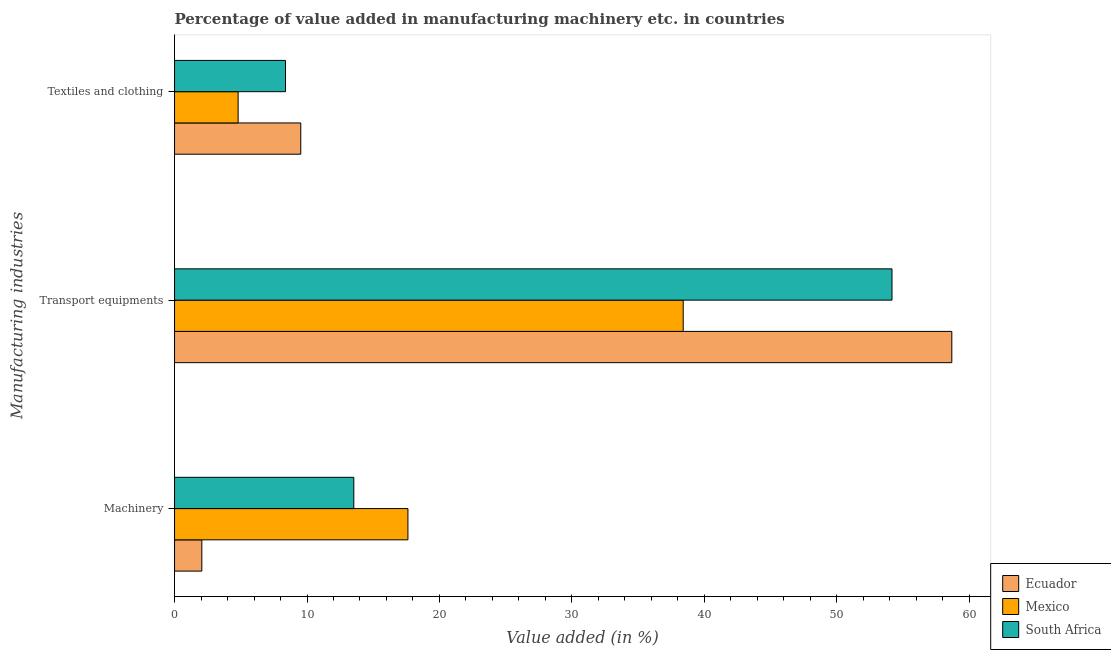How many groups of bars are there?
Keep it short and to the point. 3. Are the number of bars per tick equal to the number of legend labels?
Give a very brief answer. Yes. Are the number of bars on each tick of the Y-axis equal?
Offer a terse response. Yes. How many bars are there on the 2nd tick from the top?
Offer a very short reply. 3. How many bars are there on the 1st tick from the bottom?
Provide a short and direct response. 3. What is the label of the 3rd group of bars from the top?
Your answer should be very brief. Machinery. What is the value added in manufacturing textile and clothing in Ecuador?
Give a very brief answer. 9.53. Across all countries, what is the maximum value added in manufacturing machinery?
Your answer should be very brief. 17.62. Across all countries, what is the minimum value added in manufacturing machinery?
Ensure brevity in your answer.  2.06. In which country was the value added in manufacturing transport equipments maximum?
Provide a short and direct response. Ecuador. In which country was the value added in manufacturing machinery minimum?
Offer a very short reply. Ecuador. What is the total value added in manufacturing textile and clothing in the graph?
Offer a terse response. 22.71. What is the difference between the value added in manufacturing textile and clothing in Ecuador and that in South Africa?
Ensure brevity in your answer.  1.15. What is the difference between the value added in manufacturing machinery in South Africa and the value added in manufacturing transport equipments in Ecuador?
Offer a very short reply. -45.15. What is the average value added in manufacturing machinery per country?
Provide a short and direct response. 11.07. What is the difference between the value added in manufacturing textile and clothing and value added in manufacturing transport equipments in Ecuador?
Make the answer very short. -49.16. In how many countries, is the value added in manufacturing transport equipments greater than 52 %?
Provide a succinct answer. 2. What is the ratio of the value added in manufacturing machinery in South Africa to that in Ecuador?
Ensure brevity in your answer.  6.57. Is the value added in manufacturing transport equipments in Ecuador less than that in South Africa?
Offer a terse response. No. What is the difference between the highest and the second highest value added in manufacturing textile and clothing?
Give a very brief answer. 1.15. What is the difference between the highest and the lowest value added in manufacturing transport equipments?
Provide a short and direct response. 20.28. What does the 2nd bar from the top in Transport equipments represents?
Your response must be concise. Mexico. How many bars are there?
Offer a terse response. 9. Does the graph contain grids?
Your answer should be compact. No. Where does the legend appear in the graph?
Offer a terse response. Bottom right. How many legend labels are there?
Make the answer very short. 3. How are the legend labels stacked?
Ensure brevity in your answer.  Vertical. What is the title of the graph?
Make the answer very short. Percentage of value added in manufacturing machinery etc. in countries. Does "Angola" appear as one of the legend labels in the graph?
Give a very brief answer. No. What is the label or title of the X-axis?
Provide a succinct answer. Value added (in %). What is the label or title of the Y-axis?
Make the answer very short. Manufacturing industries. What is the Value added (in %) in Ecuador in Machinery?
Keep it short and to the point. 2.06. What is the Value added (in %) of Mexico in Machinery?
Keep it short and to the point. 17.62. What is the Value added (in %) of South Africa in Machinery?
Provide a short and direct response. 13.54. What is the Value added (in %) of Ecuador in Transport equipments?
Provide a succinct answer. 58.69. What is the Value added (in %) in Mexico in Transport equipments?
Offer a very short reply. 38.4. What is the Value added (in %) of South Africa in Transport equipments?
Keep it short and to the point. 54.17. What is the Value added (in %) of Ecuador in Textiles and clothing?
Offer a terse response. 9.53. What is the Value added (in %) in Mexico in Textiles and clothing?
Your answer should be compact. 4.8. What is the Value added (in %) of South Africa in Textiles and clothing?
Your answer should be compact. 8.38. Across all Manufacturing industries, what is the maximum Value added (in %) in Ecuador?
Offer a terse response. 58.69. Across all Manufacturing industries, what is the maximum Value added (in %) of Mexico?
Your answer should be compact. 38.4. Across all Manufacturing industries, what is the maximum Value added (in %) of South Africa?
Offer a very short reply. 54.17. Across all Manufacturing industries, what is the minimum Value added (in %) of Ecuador?
Offer a terse response. 2.06. Across all Manufacturing industries, what is the minimum Value added (in %) in Mexico?
Ensure brevity in your answer.  4.8. Across all Manufacturing industries, what is the minimum Value added (in %) of South Africa?
Offer a very short reply. 8.38. What is the total Value added (in %) of Ecuador in the graph?
Make the answer very short. 70.27. What is the total Value added (in %) of Mexico in the graph?
Keep it short and to the point. 60.83. What is the total Value added (in %) of South Africa in the graph?
Your answer should be very brief. 76.08. What is the difference between the Value added (in %) of Ecuador in Machinery and that in Transport equipments?
Provide a succinct answer. -56.63. What is the difference between the Value added (in %) in Mexico in Machinery and that in Transport equipments?
Your response must be concise. -20.78. What is the difference between the Value added (in %) of South Africa in Machinery and that in Transport equipments?
Offer a terse response. -40.63. What is the difference between the Value added (in %) of Ecuador in Machinery and that in Textiles and clothing?
Provide a short and direct response. -7.47. What is the difference between the Value added (in %) of Mexico in Machinery and that in Textiles and clothing?
Offer a very short reply. 12.82. What is the difference between the Value added (in %) of South Africa in Machinery and that in Textiles and clothing?
Make the answer very short. 5.16. What is the difference between the Value added (in %) in Ecuador in Transport equipments and that in Textiles and clothing?
Your answer should be very brief. 49.16. What is the difference between the Value added (in %) in Mexico in Transport equipments and that in Textiles and clothing?
Your answer should be very brief. 33.6. What is the difference between the Value added (in %) of South Africa in Transport equipments and that in Textiles and clothing?
Make the answer very short. 45.79. What is the difference between the Value added (in %) in Ecuador in Machinery and the Value added (in %) in Mexico in Transport equipments?
Provide a succinct answer. -36.35. What is the difference between the Value added (in %) of Ecuador in Machinery and the Value added (in %) of South Africa in Transport equipments?
Your answer should be very brief. -52.11. What is the difference between the Value added (in %) of Mexico in Machinery and the Value added (in %) of South Africa in Transport equipments?
Ensure brevity in your answer.  -36.55. What is the difference between the Value added (in %) of Ecuador in Machinery and the Value added (in %) of Mexico in Textiles and clothing?
Ensure brevity in your answer.  -2.74. What is the difference between the Value added (in %) of Ecuador in Machinery and the Value added (in %) of South Africa in Textiles and clothing?
Your answer should be very brief. -6.32. What is the difference between the Value added (in %) of Mexico in Machinery and the Value added (in %) of South Africa in Textiles and clothing?
Provide a short and direct response. 9.24. What is the difference between the Value added (in %) in Ecuador in Transport equipments and the Value added (in %) in Mexico in Textiles and clothing?
Give a very brief answer. 53.89. What is the difference between the Value added (in %) in Ecuador in Transport equipments and the Value added (in %) in South Africa in Textiles and clothing?
Provide a short and direct response. 50.31. What is the difference between the Value added (in %) of Mexico in Transport equipments and the Value added (in %) of South Africa in Textiles and clothing?
Give a very brief answer. 30.03. What is the average Value added (in %) in Ecuador per Manufacturing industries?
Your response must be concise. 23.42. What is the average Value added (in %) of Mexico per Manufacturing industries?
Your answer should be very brief. 20.28. What is the average Value added (in %) in South Africa per Manufacturing industries?
Your answer should be compact. 25.36. What is the difference between the Value added (in %) of Ecuador and Value added (in %) of Mexico in Machinery?
Your answer should be very brief. -15.56. What is the difference between the Value added (in %) of Ecuador and Value added (in %) of South Africa in Machinery?
Offer a very short reply. -11.48. What is the difference between the Value added (in %) of Mexico and Value added (in %) of South Africa in Machinery?
Your response must be concise. 4.09. What is the difference between the Value added (in %) of Ecuador and Value added (in %) of Mexico in Transport equipments?
Your response must be concise. 20.28. What is the difference between the Value added (in %) in Ecuador and Value added (in %) in South Africa in Transport equipments?
Your answer should be very brief. 4.52. What is the difference between the Value added (in %) of Mexico and Value added (in %) of South Africa in Transport equipments?
Offer a terse response. -15.76. What is the difference between the Value added (in %) in Ecuador and Value added (in %) in Mexico in Textiles and clothing?
Offer a terse response. 4.73. What is the difference between the Value added (in %) in Ecuador and Value added (in %) in South Africa in Textiles and clothing?
Offer a terse response. 1.15. What is the difference between the Value added (in %) of Mexico and Value added (in %) of South Africa in Textiles and clothing?
Provide a short and direct response. -3.58. What is the ratio of the Value added (in %) in Ecuador in Machinery to that in Transport equipments?
Ensure brevity in your answer.  0.04. What is the ratio of the Value added (in %) in Mexico in Machinery to that in Transport equipments?
Keep it short and to the point. 0.46. What is the ratio of the Value added (in %) in South Africa in Machinery to that in Transport equipments?
Offer a terse response. 0.25. What is the ratio of the Value added (in %) in Ecuador in Machinery to that in Textiles and clothing?
Offer a terse response. 0.22. What is the ratio of the Value added (in %) of Mexico in Machinery to that in Textiles and clothing?
Provide a succinct answer. 3.67. What is the ratio of the Value added (in %) of South Africa in Machinery to that in Textiles and clothing?
Provide a succinct answer. 1.62. What is the ratio of the Value added (in %) of Ecuador in Transport equipments to that in Textiles and clothing?
Provide a succinct answer. 6.16. What is the ratio of the Value added (in %) of Mexico in Transport equipments to that in Textiles and clothing?
Your answer should be very brief. 8. What is the ratio of the Value added (in %) of South Africa in Transport equipments to that in Textiles and clothing?
Provide a succinct answer. 6.46. What is the difference between the highest and the second highest Value added (in %) in Ecuador?
Your answer should be very brief. 49.16. What is the difference between the highest and the second highest Value added (in %) of Mexico?
Provide a short and direct response. 20.78. What is the difference between the highest and the second highest Value added (in %) of South Africa?
Give a very brief answer. 40.63. What is the difference between the highest and the lowest Value added (in %) in Ecuador?
Ensure brevity in your answer.  56.63. What is the difference between the highest and the lowest Value added (in %) in Mexico?
Provide a succinct answer. 33.6. What is the difference between the highest and the lowest Value added (in %) of South Africa?
Offer a very short reply. 45.79. 